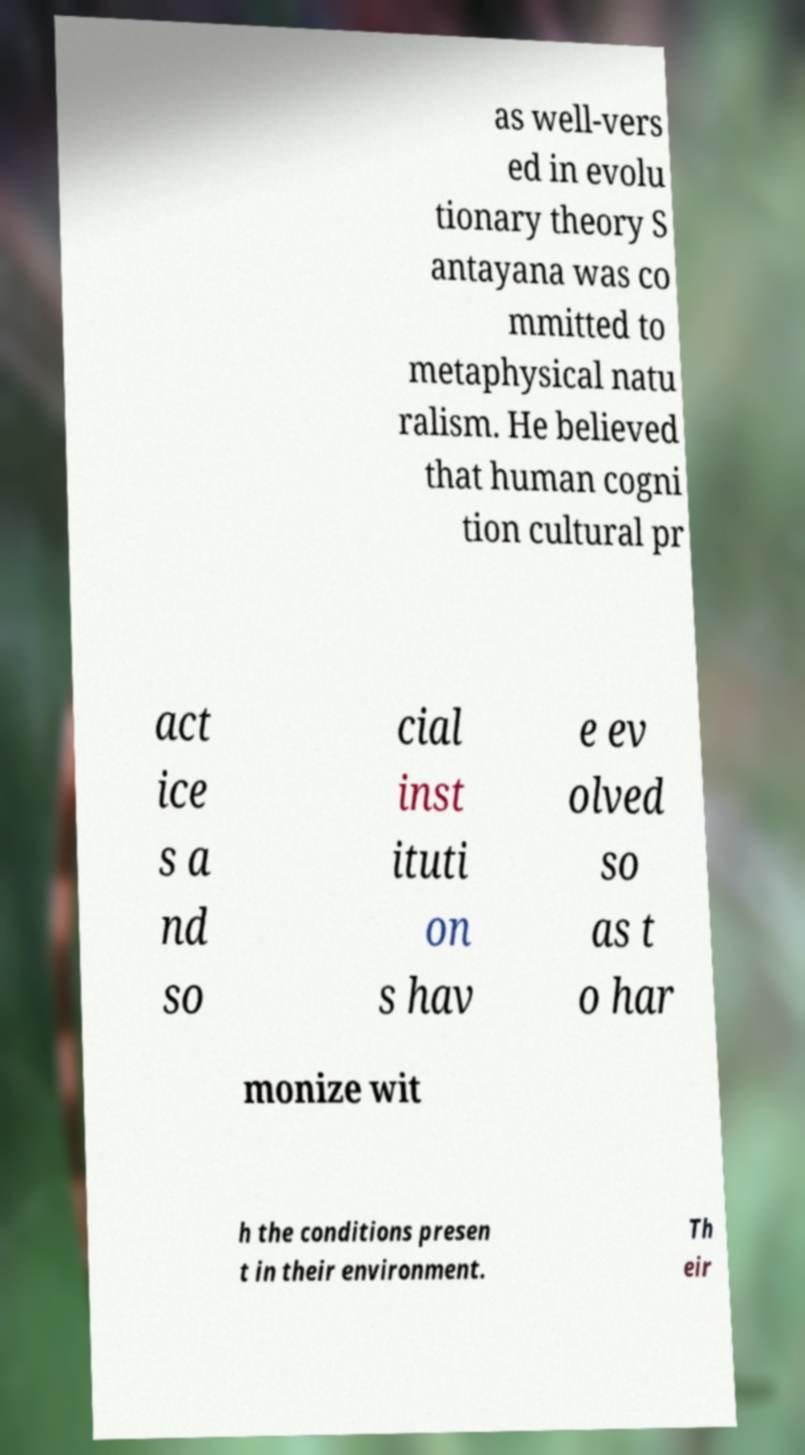Could you assist in decoding the text presented in this image and type it out clearly? as well-vers ed in evolu tionary theory S antayana was co mmitted to metaphysical natu ralism. He believed that human cogni tion cultural pr act ice s a nd so cial inst ituti on s hav e ev olved so as t o har monize wit h the conditions presen t in their environment. Th eir 